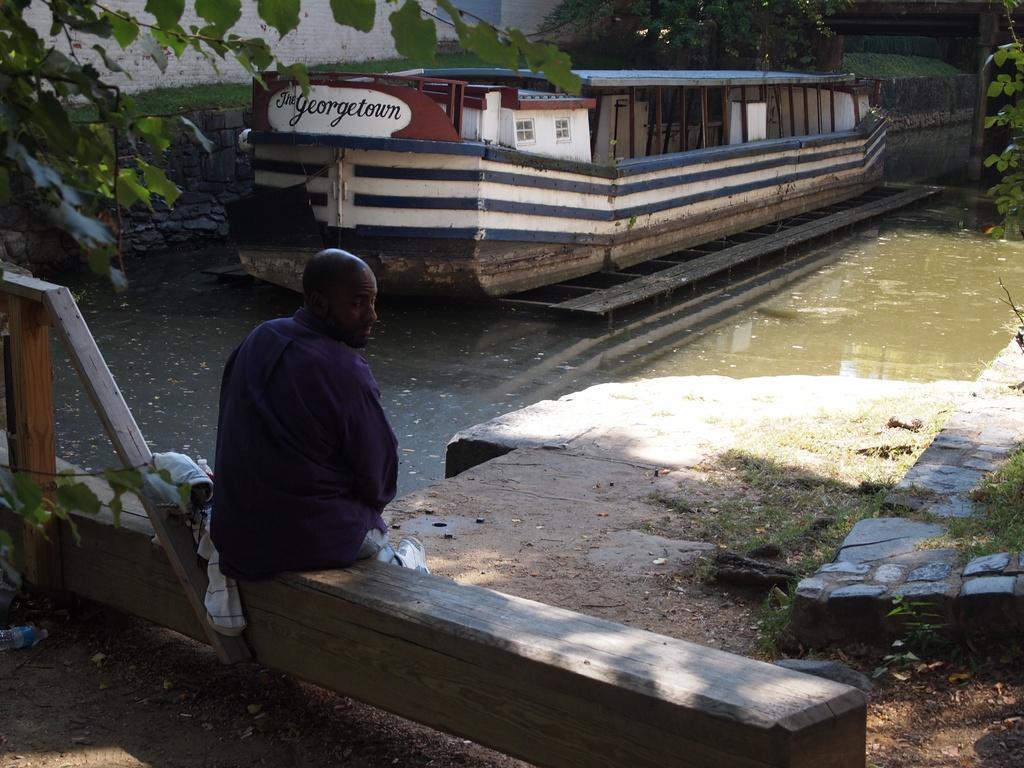Can you describe this image briefly? In the foreground of the image we can see a person sitting on the wooden log with some clothes and wood pieces. In the center of the image we can see a boat with some text on it is placed in the water. In the background, we can see a building, group of trees and grass. 